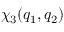Convert formula to latex. <formula><loc_0><loc_0><loc_500><loc_500>\chi _ { 3 } ( q _ { 1 } , q _ { 2 } )</formula> 